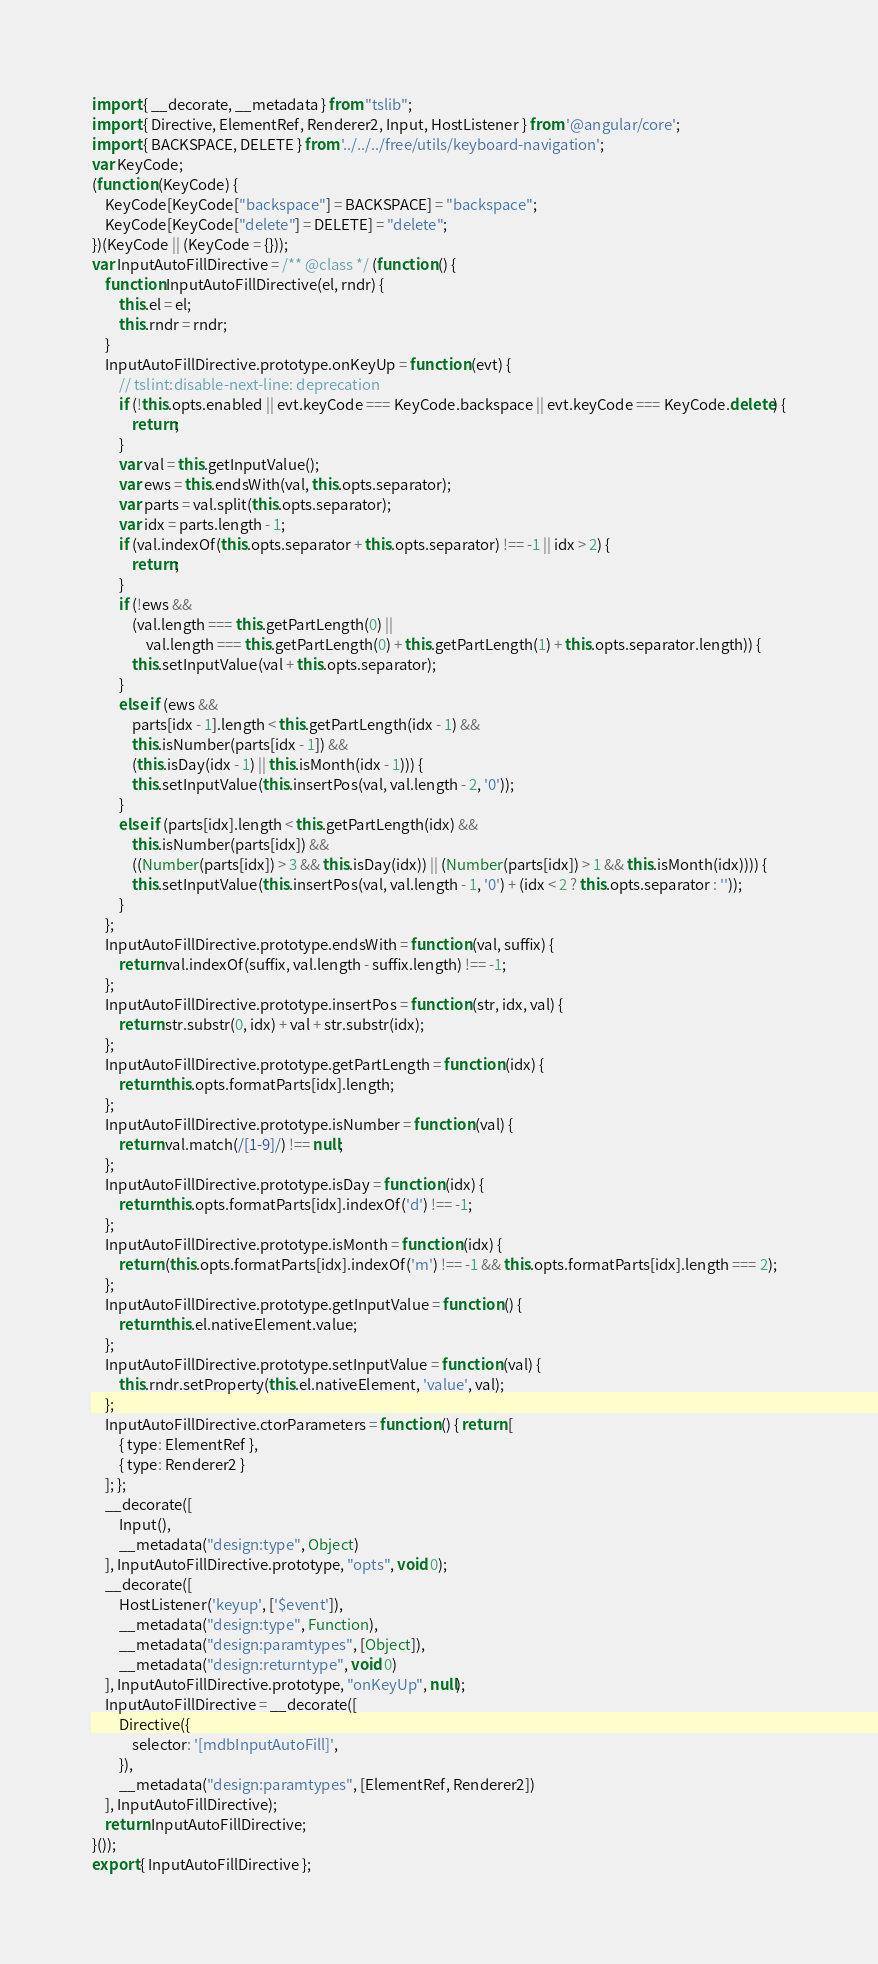Convert code to text. <code><loc_0><loc_0><loc_500><loc_500><_JavaScript_>import { __decorate, __metadata } from "tslib";
import { Directive, ElementRef, Renderer2, Input, HostListener } from '@angular/core';
import { BACKSPACE, DELETE } from '../../../free/utils/keyboard-navigation';
var KeyCode;
(function (KeyCode) {
    KeyCode[KeyCode["backspace"] = BACKSPACE] = "backspace";
    KeyCode[KeyCode["delete"] = DELETE] = "delete";
})(KeyCode || (KeyCode = {}));
var InputAutoFillDirective = /** @class */ (function () {
    function InputAutoFillDirective(el, rndr) {
        this.el = el;
        this.rndr = rndr;
    }
    InputAutoFillDirective.prototype.onKeyUp = function (evt) {
        // tslint:disable-next-line: deprecation
        if (!this.opts.enabled || evt.keyCode === KeyCode.backspace || evt.keyCode === KeyCode.delete) {
            return;
        }
        var val = this.getInputValue();
        var ews = this.endsWith(val, this.opts.separator);
        var parts = val.split(this.opts.separator);
        var idx = parts.length - 1;
        if (val.indexOf(this.opts.separator + this.opts.separator) !== -1 || idx > 2) {
            return;
        }
        if (!ews &&
            (val.length === this.getPartLength(0) ||
                val.length === this.getPartLength(0) + this.getPartLength(1) + this.opts.separator.length)) {
            this.setInputValue(val + this.opts.separator);
        }
        else if (ews &&
            parts[idx - 1].length < this.getPartLength(idx - 1) &&
            this.isNumber(parts[idx - 1]) &&
            (this.isDay(idx - 1) || this.isMonth(idx - 1))) {
            this.setInputValue(this.insertPos(val, val.length - 2, '0'));
        }
        else if (parts[idx].length < this.getPartLength(idx) &&
            this.isNumber(parts[idx]) &&
            ((Number(parts[idx]) > 3 && this.isDay(idx)) || (Number(parts[idx]) > 1 && this.isMonth(idx)))) {
            this.setInputValue(this.insertPos(val, val.length - 1, '0') + (idx < 2 ? this.opts.separator : ''));
        }
    };
    InputAutoFillDirective.prototype.endsWith = function (val, suffix) {
        return val.indexOf(suffix, val.length - suffix.length) !== -1;
    };
    InputAutoFillDirective.prototype.insertPos = function (str, idx, val) {
        return str.substr(0, idx) + val + str.substr(idx);
    };
    InputAutoFillDirective.prototype.getPartLength = function (idx) {
        return this.opts.formatParts[idx].length;
    };
    InputAutoFillDirective.prototype.isNumber = function (val) {
        return val.match(/[1-9]/) !== null;
    };
    InputAutoFillDirective.prototype.isDay = function (idx) {
        return this.opts.formatParts[idx].indexOf('d') !== -1;
    };
    InputAutoFillDirective.prototype.isMonth = function (idx) {
        return (this.opts.formatParts[idx].indexOf('m') !== -1 && this.opts.formatParts[idx].length === 2);
    };
    InputAutoFillDirective.prototype.getInputValue = function () {
        return this.el.nativeElement.value;
    };
    InputAutoFillDirective.prototype.setInputValue = function (val) {
        this.rndr.setProperty(this.el.nativeElement, 'value', val);
    };
    InputAutoFillDirective.ctorParameters = function () { return [
        { type: ElementRef },
        { type: Renderer2 }
    ]; };
    __decorate([
        Input(),
        __metadata("design:type", Object)
    ], InputAutoFillDirective.prototype, "opts", void 0);
    __decorate([
        HostListener('keyup', ['$event']),
        __metadata("design:type", Function),
        __metadata("design:paramtypes", [Object]),
        __metadata("design:returntype", void 0)
    ], InputAutoFillDirective.prototype, "onKeyUp", null);
    InputAutoFillDirective = __decorate([
        Directive({
            selector: '[mdbInputAutoFill]',
        }),
        __metadata("design:paramtypes", [ElementRef, Renderer2])
    ], InputAutoFillDirective);
    return InputAutoFillDirective;
}());
export { InputAutoFillDirective };</code> 